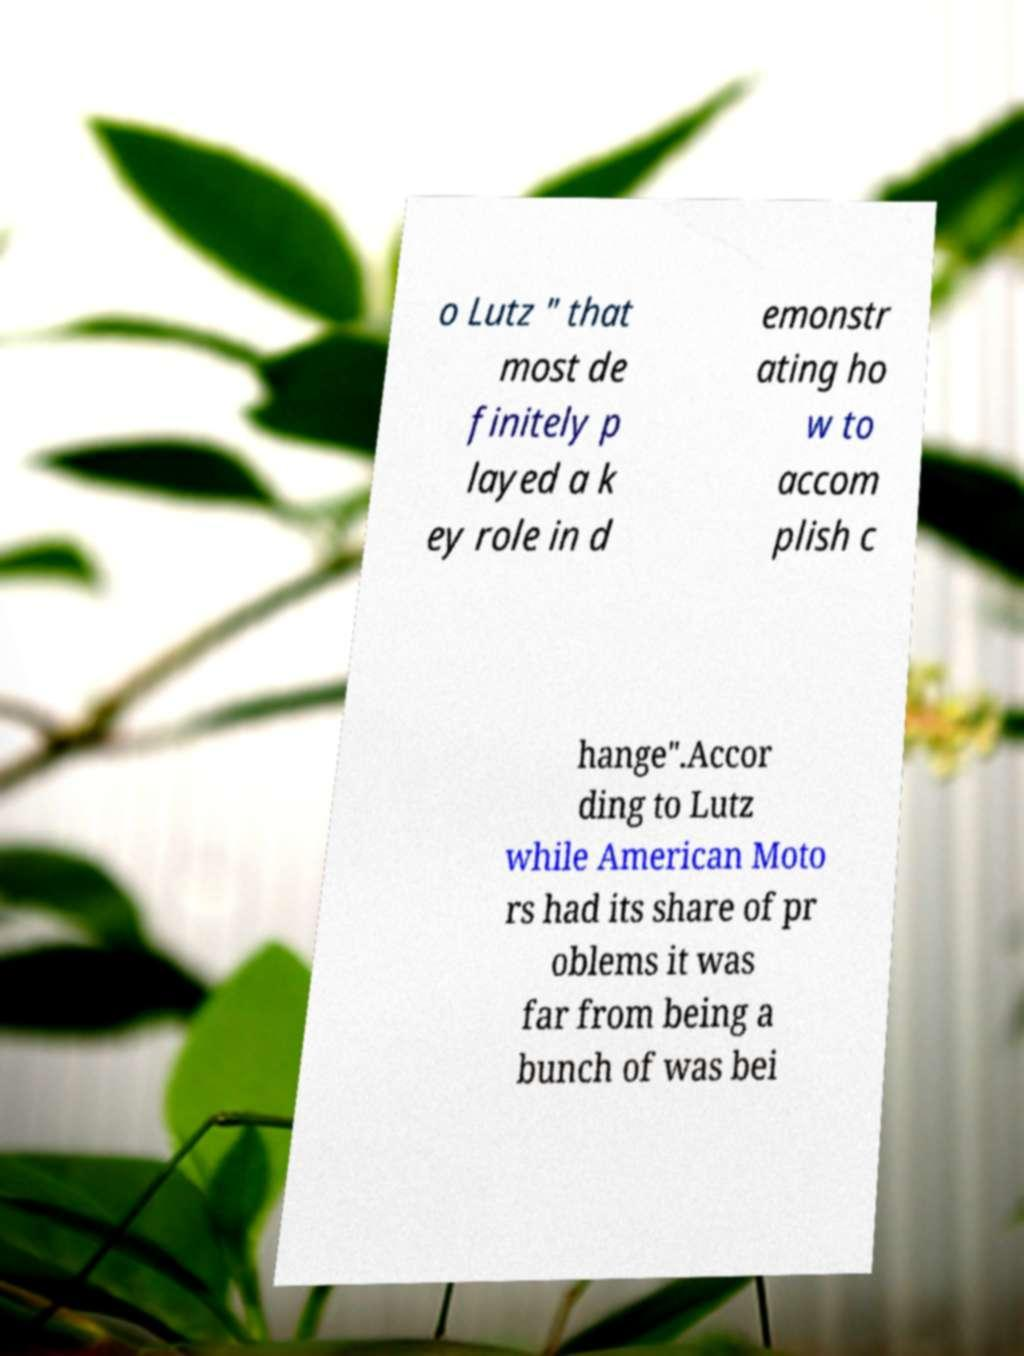Please identify and transcribe the text found in this image. o Lutz " that most de finitely p layed a k ey role in d emonstr ating ho w to accom plish c hange".Accor ding to Lutz while American Moto rs had its share of pr oblems it was far from being a bunch of was bei 